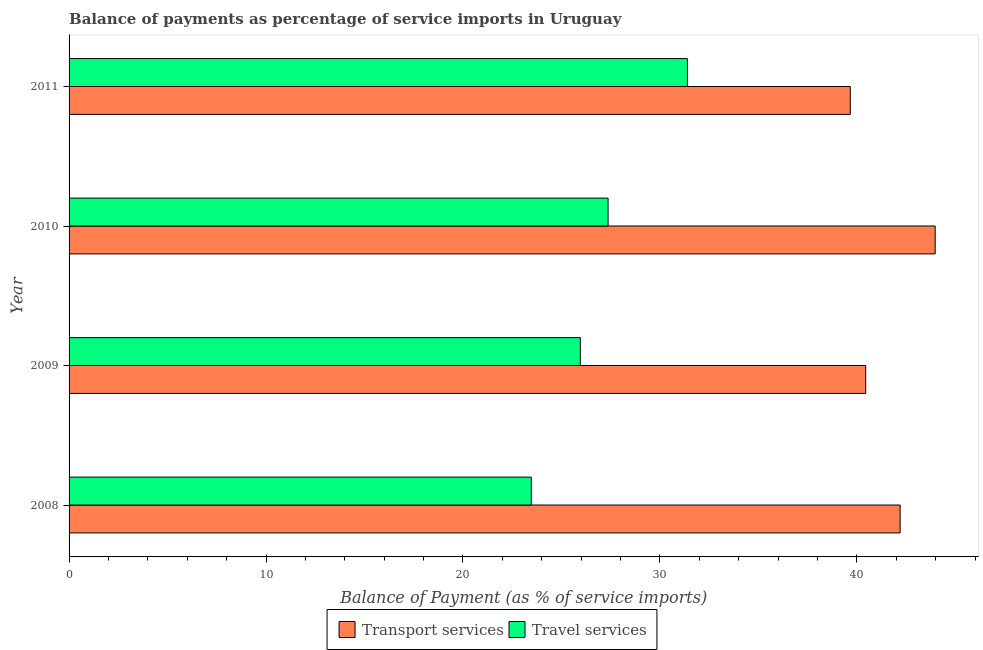Are the number of bars on each tick of the Y-axis equal?
Provide a succinct answer. Yes. How many bars are there on the 1st tick from the top?
Offer a very short reply. 2. How many bars are there on the 2nd tick from the bottom?
Your answer should be very brief. 2. In how many cases, is the number of bars for a given year not equal to the number of legend labels?
Make the answer very short. 0. What is the balance of payments of transport services in 2010?
Provide a succinct answer. 43.98. Across all years, what is the maximum balance of payments of transport services?
Your answer should be compact. 43.98. Across all years, what is the minimum balance of payments of travel services?
Provide a succinct answer. 23.47. In which year was the balance of payments of travel services minimum?
Provide a short and direct response. 2008. What is the total balance of payments of transport services in the graph?
Your response must be concise. 166.28. What is the difference between the balance of payments of travel services in 2008 and that in 2011?
Your response must be concise. -7.92. What is the difference between the balance of payments of transport services in 2009 and the balance of payments of travel services in 2010?
Your response must be concise. 13.08. What is the average balance of payments of travel services per year?
Keep it short and to the point. 27.05. In the year 2008, what is the difference between the balance of payments of transport services and balance of payments of travel services?
Your response must be concise. 18.73. In how many years, is the balance of payments of travel services greater than 20 %?
Make the answer very short. 4. What is the ratio of the balance of payments of travel services in 2008 to that in 2010?
Your answer should be very brief. 0.86. What is the difference between the highest and the second highest balance of payments of transport services?
Offer a very short reply. 1.78. What is the difference between the highest and the lowest balance of payments of transport services?
Provide a succinct answer. 4.31. What does the 2nd bar from the top in 2010 represents?
Provide a short and direct response. Transport services. What does the 1st bar from the bottom in 2008 represents?
Your response must be concise. Transport services. Are all the bars in the graph horizontal?
Provide a succinct answer. Yes. How many years are there in the graph?
Provide a succinct answer. 4. What is the difference between two consecutive major ticks on the X-axis?
Provide a short and direct response. 10. Are the values on the major ticks of X-axis written in scientific E-notation?
Provide a short and direct response. No. Does the graph contain any zero values?
Offer a terse response. No. Where does the legend appear in the graph?
Keep it short and to the point. Bottom center. What is the title of the graph?
Provide a succinct answer. Balance of payments as percentage of service imports in Uruguay. What is the label or title of the X-axis?
Provide a short and direct response. Balance of Payment (as % of service imports). What is the label or title of the Y-axis?
Give a very brief answer. Year. What is the Balance of Payment (as % of service imports) of Transport services in 2008?
Make the answer very short. 42.2. What is the Balance of Payment (as % of service imports) in Travel services in 2008?
Offer a terse response. 23.47. What is the Balance of Payment (as % of service imports) in Transport services in 2009?
Offer a terse response. 40.45. What is the Balance of Payment (as % of service imports) in Travel services in 2009?
Provide a short and direct response. 25.96. What is the Balance of Payment (as % of service imports) of Transport services in 2010?
Provide a short and direct response. 43.98. What is the Balance of Payment (as % of service imports) of Travel services in 2010?
Provide a short and direct response. 27.37. What is the Balance of Payment (as % of service imports) in Transport services in 2011?
Provide a succinct answer. 39.66. What is the Balance of Payment (as % of service imports) of Travel services in 2011?
Offer a very short reply. 31.39. Across all years, what is the maximum Balance of Payment (as % of service imports) in Transport services?
Ensure brevity in your answer.  43.98. Across all years, what is the maximum Balance of Payment (as % of service imports) in Travel services?
Your answer should be very brief. 31.39. Across all years, what is the minimum Balance of Payment (as % of service imports) in Transport services?
Give a very brief answer. 39.66. Across all years, what is the minimum Balance of Payment (as % of service imports) in Travel services?
Make the answer very short. 23.47. What is the total Balance of Payment (as % of service imports) in Transport services in the graph?
Provide a succinct answer. 166.28. What is the total Balance of Payment (as % of service imports) in Travel services in the graph?
Keep it short and to the point. 108.19. What is the difference between the Balance of Payment (as % of service imports) of Transport services in 2008 and that in 2009?
Ensure brevity in your answer.  1.75. What is the difference between the Balance of Payment (as % of service imports) of Travel services in 2008 and that in 2009?
Your response must be concise. -2.49. What is the difference between the Balance of Payment (as % of service imports) in Transport services in 2008 and that in 2010?
Your answer should be very brief. -1.78. What is the difference between the Balance of Payment (as % of service imports) of Travel services in 2008 and that in 2010?
Your response must be concise. -3.9. What is the difference between the Balance of Payment (as % of service imports) of Transport services in 2008 and that in 2011?
Make the answer very short. 2.53. What is the difference between the Balance of Payment (as % of service imports) in Travel services in 2008 and that in 2011?
Offer a terse response. -7.92. What is the difference between the Balance of Payment (as % of service imports) of Transport services in 2009 and that in 2010?
Ensure brevity in your answer.  -3.53. What is the difference between the Balance of Payment (as % of service imports) in Travel services in 2009 and that in 2010?
Your answer should be very brief. -1.41. What is the difference between the Balance of Payment (as % of service imports) of Transport services in 2009 and that in 2011?
Your answer should be very brief. 0.78. What is the difference between the Balance of Payment (as % of service imports) of Travel services in 2009 and that in 2011?
Offer a very short reply. -5.44. What is the difference between the Balance of Payment (as % of service imports) of Transport services in 2010 and that in 2011?
Give a very brief answer. 4.31. What is the difference between the Balance of Payment (as % of service imports) in Travel services in 2010 and that in 2011?
Provide a succinct answer. -4.03. What is the difference between the Balance of Payment (as % of service imports) in Transport services in 2008 and the Balance of Payment (as % of service imports) in Travel services in 2009?
Keep it short and to the point. 16.24. What is the difference between the Balance of Payment (as % of service imports) in Transport services in 2008 and the Balance of Payment (as % of service imports) in Travel services in 2010?
Your response must be concise. 14.83. What is the difference between the Balance of Payment (as % of service imports) in Transport services in 2008 and the Balance of Payment (as % of service imports) in Travel services in 2011?
Your answer should be compact. 10.8. What is the difference between the Balance of Payment (as % of service imports) of Transport services in 2009 and the Balance of Payment (as % of service imports) of Travel services in 2010?
Provide a succinct answer. 13.08. What is the difference between the Balance of Payment (as % of service imports) of Transport services in 2009 and the Balance of Payment (as % of service imports) of Travel services in 2011?
Your answer should be very brief. 9.05. What is the difference between the Balance of Payment (as % of service imports) in Transport services in 2010 and the Balance of Payment (as % of service imports) in Travel services in 2011?
Your answer should be very brief. 12.58. What is the average Balance of Payment (as % of service imports) in Transport services per year?
Your answer should be compact. 41.57. What is the average Balance of Payment (as % of service imports) in Travel services per year?
Keep it short and to the point. 27.05. In the year 2008, what is the difference between the Balance of Payment (as % of service imports) of Transport services and Balance of Payment (as % of service imports) of Travel services?
Provide a succinct answer. 18.73. In the year 2009, what is the difference between the Balance of Payment (as % of service imports) of Transport services and Balance of Payment (as % of service imports) of Travel services?
Provide a succinct answer. 14.49. In the year 2010, what is the difference between the Balance of Payment (as % of service imports) of Transport services and Balance of Payment (as % of service imports) of Travel services?
Offer a very short reply. 16.61. In the year 2011, what is the difference between the Balance of Payment (as % of service imports) of Transport services and Balance of Payment (as % of service imports) of Travel services?
Provide a short and direct response. 8.27. What is the ratio of the Balance of Payment (as % of service imports) in Transport services in 2008 to that in 2009?
Your response must be concise. 1.04. What is the ratio of the Balance of Payment (as % of service imports) in Travel services in 2008 to that in 2009?
Offer a very short reply. 0.9. What is the ratio of the Balance of Payment (as % of service imports) in Transport services in 2008 to that in 2010?
Make the answer very short. 0.96. What is the ratio of the Balance of Payment (as % of service imports) of Travel services in 2008 to that in 2010?
Ensure brevity in your answer.  0.86. What is the ratio of the Balance of Payment (as % of service imports) in Transport services in 2008 to that in 2011?
Your answer should be compact. 1.06. What is the ratio of the Balance of Payment (as % of service imports) in Travel services in 2008 to that in 2011?
Provide a succinct answer. 0.75. What is the ratio of the Balance of Payment (as % of service imports) in Transport services in 2009 to that in 2010?
Keep it short and to the point. 0.92. What is the ratio of the Balance of Payment (as % of service imports) in Travel services in 2009 to that in 2010?
Make the answer very short. 0.95. What is the ratio of the Balance of Payment (as % of service imports) of Transport services in 2009 to that in 2011?
Make the answer very short. 1.02. What is the ratio of the Balance of Payment (as % of service imports) of Travel services in 2009 to that in 2011?
Your answer should be compact. 0.83. What is the ratio of the Balance of Payment (as % of service imports) in Transport services in 2010 to that in 2011?
Give a very brief answer. 1.11. What is the ratio of the Balance of Payment (as % of service imports) of Travel services in 2010 to that in 2011?
Your answer should be compact. 0.87. What is the difference between the highest and the second highest Balance of Payment (as % of service imports) of Transport services?
Your answer should be very brief. 1.78. What is the difference between the highest and the second highest Balance of Payment (as % of service imports) in Travel services?
Give a very brief answer. 4.03. What is the difference between the highest and the lowest Balance of Payment (as % of service imports) of Transport services?
Your answer should be compact. 4.31. What is the difference between the highest and the lowest Balance of Payment (as % of service imports) of Travel services?
Give a very brief answer. 7.92. 